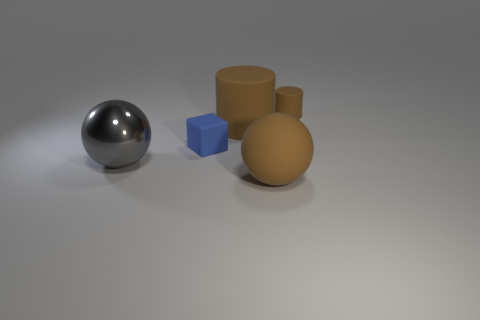Subtract all brown cylinders. How many were subtracted if there are1brown cylinders left? 1 Add 1 rubber cylinders. How many objects exist? 6 Subtract all cubes. How many objects are left? 4 Subtract 0 blue cylinders. How many objects are left? 5 Subtract all large matte objects. Subtract all spheres. How many objects are left? 1 Add 4 brown matte cylinders. How many brown matte cylinders are left? 6 Add 1 big blue blocks. How many big blue blocks exist? 1 